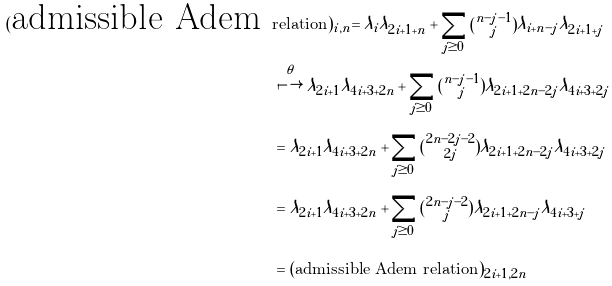<formula> <loc_0><loc_0><loc_500><loc_500>( \text {admissible Adem } & \text {relation} ) _ { i , n } = \lambda _ { i } \lambda _ { 2 i + 1 + n } + \sum _ { j \geq 0 } \tbinom { n - j - 1 } { j } \lambda _ { i + n - j } \lambda _ { 2 i + 1 + j } \\ & \stackrel { \theta } { \longmapsto } \lambda _ { 2 i + 1 } \lambda _ { 4 i + 3 + 2 n } + \sum _ { j \geq 0 } \tbinom { n - j - 1 } { j } \lambda _ { 2 i + 1 + 2 n - 2 j } \lambda _ { 4 i + 3 + 2 j } \\ & = \lambda _ { 2 i + 1 } \lambda _ { 4 i + 3 + 2 n } + \sum _ { j \geq 0 } \tbinom { 2 n - 2 j - 2 } { 2 j } \lambda _ { 2 i + 1 + 2 n - 2 j } \lambda _ { 4 i + 3 + 2 j } \\ & = \lambda _ { 2 i + 1 } \lambda _ { 4 i + 3 + 2 n } + \sum _ { j \geq 0 } \tbinom { 2 n - j - 2 } { j } \lambda _ { 2 i + 1 + 2 n - j } \lambda _ { 4 i + 3 + j } \\ & = ( \text {admissible Adem relation} ) _ { 2 i + 1 , 2 n }</formula> 